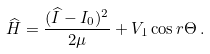<formula> <loc_0><loc_0><loc_500><loc_500>\widehat { H } = \frac { ( \widehat { I } - I _ { 0 } ) ^ { 2 } } { 2 \mu } + V _ { 1 } \cos { r \Theta } \, .</formula> 